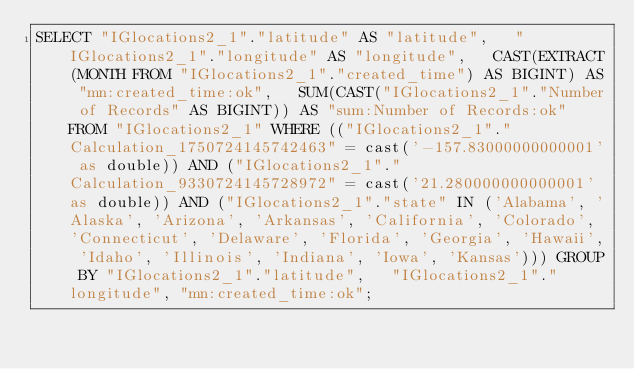Convert code to text. <code><loc_0><loc_0><loc_500><loc_500><_SQL_>SELECT "IGlocations2_1"."latitude" AS "latitude",   "IGlocations2_1"."longitude" AS "longitude",   CAST(EXTRACT(MONTH FROM "IGlocations2_1"."created_time") AS BIGINT) AS "mn:created_time:ok",   SUM(CAST("IGlocations2_1"."Number of Records" AS BIGINT)) AS "sum:Number of Records:ok" FROM "IGlocations2_1" WHERE (("IGlocations2_1"."Calculation_1750724145742463" = cast('-157.83000000000001' as double)) AND ("IGlocations2_1"."Calculation_9330724145728972" = cast('21.280000000000001' as double)) AND ("IGlocations2_1"."state" IN ('Alabama', 'Alaska', 'Arizona', 'Arkansas', 'California', 'Colorado', 'Connecticut', 'Delaware', 'Florida', 'Georgia', 'Hawaii', 'Idaho', 'Illinois', 'Indiana', 'Iowa', 'Kansas'))) GROUP BY "IGlocations2_1"."latitude",   "IGlocations2_1"."longitude", "mn:created_time:ok";
</code> 